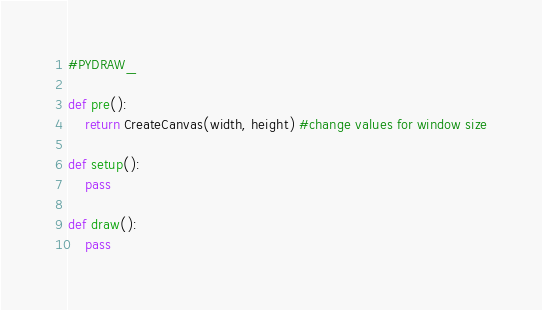Convert code to text. <code><loc_0><loc_0><loc_500><loc_500><_Python_>#PYDRAW_

def pre():
    return CreateCanvas(width, height) #change values for window size

def setup():
    pass

def draw():
    pass</code> 